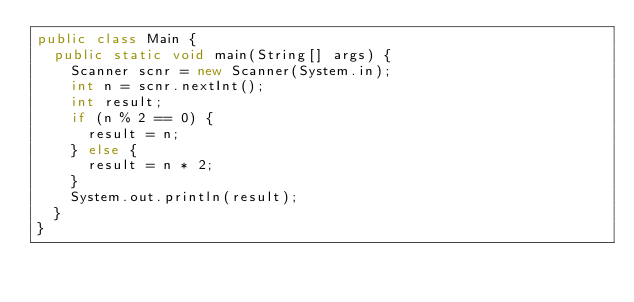<code> <loc_0><loc_0><loc_500><loc_500><_Java_>public class Main {
	public static void main(String[] args) {
		Scanner scnr = new Scanner(System.in);
		int n = scnr.nextInt();
		int result;
		if (n % 2 == 0) {
			result = n;
		} else {
			result = n * 2;
		}
		System.out.println(result);
	}
}</code> 